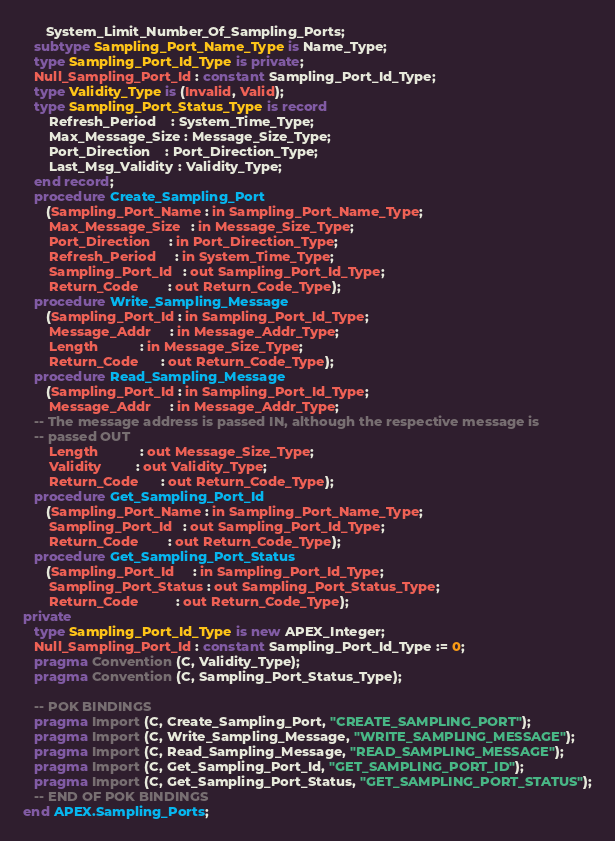Convert code to text. <code><loc_0><loc_0><loc_500><loc_500><_Ada_>      System_Limit_Number_Of_Sampling_Ports;
   subtype Sampling_Port_Name_Type is Name_Type;
   type Sampling_Port_Id_Type is private;
   Null_Sampling_Port_Id : constant Sampling_Port_Id_Type;
   type Validity_Type is (Invalid, Valid);
   type Sampling_Port_Status_Type is record
       Refresh_Period    : System_Time_Type;
       Max_Message_Size : Message_Size_Type;
       Port_Direction    : Port_Direction_Type;
       Last_Msg_Validity : Validity_Type;
   end record;
   procedure Create_Sampling_Port
      (Sampling_Port_Name : in Sampling_Port_Name_Type;
       Max_Message_Size   : in Message_Size_Type;
       Port_Direction     : in Port_Direction_Type;
       Refresh_Period     : in System_Time_Type;
       Sampling_Port_Id   : out Sampling_Port_Id_Type;
       Return_Code        : out Return_Code_Type);
   procedure Write_Sampling_Message
      (Sampling_Port_Id : in Sampling_Port_Id_Type;
       Message_Addr     : in Message_Addr_Type;
       Length           : in Message_Size_Type;
       Return_Code      : out Return_Code_Type);
   procedure Read_Sampling_Message
      (Sampling_Port_Id : in Sampling_Port_Id_Type;
       Message_Addr     : in Message_Addr_Type;
   -- The message address is passed IN, although the respective message is
   -- passed OUT
       Length           : out Message_Size_Type;
       Validity         : out Validity_Type;
       Return_Code      : out Return_Code_Type);
   procedure Get_Sampling_Port_Id
      (Sampling_Port_Name : in Sampling_Port_Name_Type;
       Sampling_Port_Id   : out Sampling_Port_Id_Type;
       Return_Code        : out Return_Code_Type);
   procedure Get_Sampling_Port_Status
      (Sampling_Port_Id     : in Sampling_Port_Id_Type;
       Sampling_Port_Status : out Sampling_Port_Status_Type;
       Return_Code          : out Return_Code_Type);
private
   type Sampling_Port_Id_Type is new APEX_Integer;
   Null_Sampling_Port_Id : constant Sampling_Port_Id_Type := 0;
   pragma Convention (C, Validity_Type);
   pragma Convention (C, Sampling_Port_Status_Type);

   -- POK BINDINGS
   pragma Import (C, Create_Sampling_Port, "CREATE_SAMPLING_PORT");
   pragma Import (C, Write_Sampling_Message, "WRITE_SAMPLING_MESSAGE");
   pragma Import (C, Read_Sampling_Message, "READ_SAMPLING_MESSAGE");
   pragma Import (C, Get_Sampling_Port_Id, "GET_SAMPLING_PORT_ID");
   pragma Import (C, Get_Sampling_Port_Status, "GET_SAMPLING_PORT_STATUS");
   -- END OF POK BINDINGS
end APEX.Sampling_Ports;
</code> 